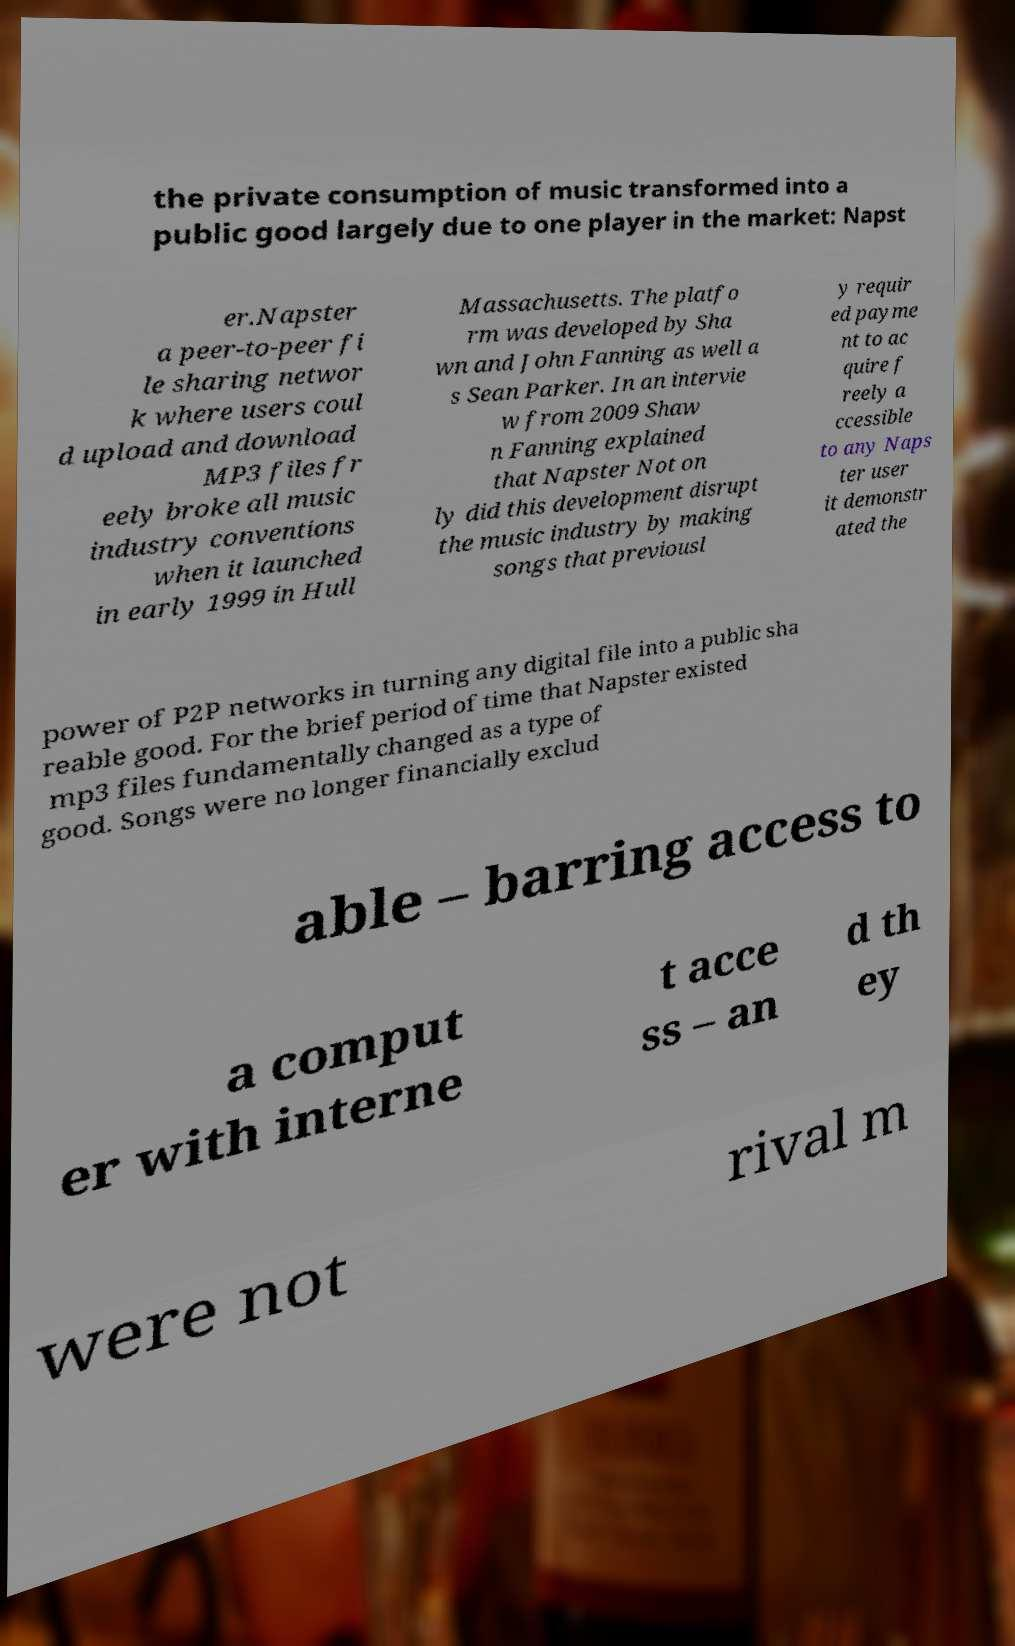There's text embedded in this image that I need extracted. Can you transcribe it verbatim? the private consumption of music transformed into a public good largely due to one player in the market: Napst er.Napster a peer-to-peer fi le sharing networ k where users coul d upload and download MP3 files fr eely broke all music industry conventions when it launched in early 1999 in Hull Massachusetts. The platfo rm was developed by Sha wn and John Fanning as well a s Sean Parker. In an intervie w from 2009 Shaw n Fanning explained that Napster Not on ly did this development disrupt the music industry by making songs that previousl y requir ed payme nt to ac quire f reely a ccessible to any Naps ter user it demonstr ated the power of P2P networks in turning any digital file into a public sha reable good. For the brief period of time that Napster existed mp3 files fundamentally changed as a type of good. Songs were no longer financially exclud able – barring access to a comput er with interne t acce ss – an d th ey were not rival m 